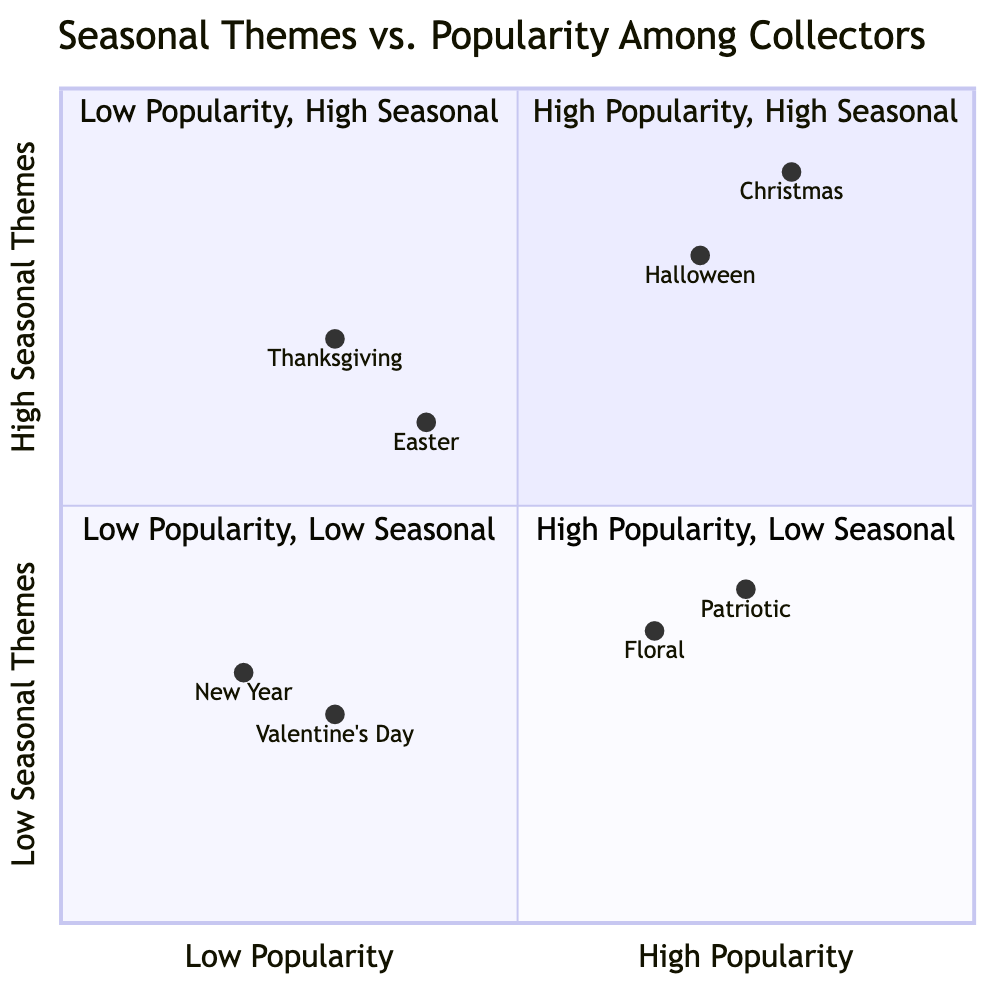What themes are in the High Popularity - High Seasonal quadrant? The High Popularity - High Seasonal quadrant contains the themes Christmas and Halloween. These themes are positioned in this quadrant because they are both highly popular among collectors and feature strong seasonal elements.
Answer: Christmas, Halloween Which theme has the lowest popularity? The theme with the lowest popularity is New Year. Looking at the values provided in the diagram, New Year scores the lowest in popularity among all the themes listed, indicating it is less sought after by collectors.
Answer: New Year How many themes have High Seasonal Themes? There are four themes with High Seasonal Themes: Christmas, Halloween, Thanksgiving, and Easter. We identify these themes based on their positioning in the diagram, where they show a strong seasonal connection.
Answer: 4 What is the score of the Patriotic theme in Popularity Among Collectors? The Patriotic theme has a score of 0.75 in Popularity Among Collectors. This score corresponds to its placement in the diagram, indicating it is quite popular among the collectors.
Answer: 0.75 Which seasonal theme is associated with Pilgrim-themed cards? The seasonal theme associated with Pilgrim-themed cards is Thanksgiving. This theme is categorized in the Low Popularity - High Seasonal Themes quadrant, showing its seasonal relevance despite lower popularity.
Answer: Thanksgiving How do the scores of Valentine's Day and New Year compare in Low Popularity - Low Seasonal quadrant? Valentine's Day has a score of 0.3 and New Year has a score of 0.2. This indicates that while both are in similar low popularity and low seasonal themes, Valentine's Day is slightly more popular than New Year.
Answer: Valentine's Day is more popular Which theme has the highest score in High Popularity - Low Seasonal quadrant? The theme with the highest score in the High Popularity - Low Seasonal quadrant is Patriotic with a score of 0.75. This score confirms its popularity among collectors despite its lower seasonal association.
Answer: Patriotic Are there any themes in the Low Popularity - Low Seasonal quadrant? Yes, the themes in the Low Popularity - Low Seasonal quadrant are New Year and Valentine's Day. This positioning reflects both their low collector popularity and seasonal relevance.
Answer: Yes, New Year and Valentine's Day What examples are given for Halloween? The examples provided for Halloween are Vintage Halloween witches and Pumpkins and harvest scenery. These examples illustrate the themes' popular imagery among collectors.
Answer: Vintage Halloween witches, Pumpkins and harvest scenery 